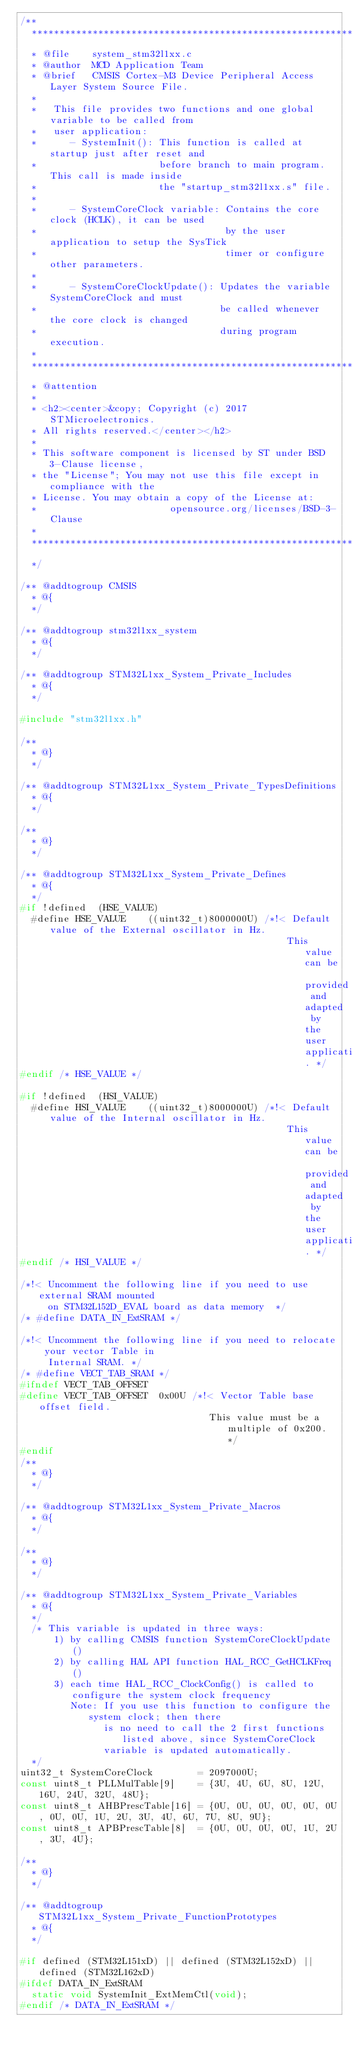<code> <loc_0><loc_0><loc_500><loc_500><_C_>/**
  ******************************************************************************
  * @file    system_stm32l1xx.c
  * @author  MCD Application Team
  * @brief   CMSIS Cortex-M3 Device Peripheral Access Layer System Source File.
  *             
  *   This file provides two functions and one global variable to be called from 
  *   user application:
  *      - SystemInit(): This function is called at startup just after reset and 
  *                      before branch to main program. This call is made inside
  *                      the "startup_stm32l1xx.s" file.
  *                        
  *      - SystemCoreClock variable: Contains the core clock (HCLK), it can be used
  *                                  by the user application to setup the SysTick 
  *                                  timer or configure other parameters.
  *                                     
  *      - SystemCoreClockUpdate(): Updates the variable SystemCoreClock and must
  *                                 be called whenever the core clock is changed
  *                                 during program execution.   
  *      
  ******************************************************************************
  * @attention
  *
  * <h2><center>&copy; Copyright (c) 2017 STMicroelectronics.
  * All rights reserved.</center></h2>
  *
  * This software component is licensed by ST under BSD 3-Clause license,
  * the "License"; You may not use this file except in compliance with the
  * License. You may obtain a copy of the License at:
  *                        opensource.org/licenses/BSD-3-Clause
  *
  ******************************************************************************
  */

/** @addtogroup CMSIS
  * @{
  */

/** @addtogroup stm32l1xx_system
  * @{
  */  
  
/** @addtogroup STM32L1xx_System_Private_Includes
  * @{
  */

#include "stm32l1xx.h"

/**
  * @}
  */

/** @addtogroup STM32L1xx_System_Private_TypesDefinitions
  * @{
  */

/**
  * @}
  */

/** @addtogroup STM32L1xx_System_Private_Defines
  * @{
  */
#if !defined  (HSE_VALUE) 
  #define HSE_VALUE    ((uint32_t)8000000U) /*!< Default value of the External oscillator in Hz.
                                                This value can be provided and adapted by the user application. */
#endif /* HSE_VALUE */

#if !defined  (HSI_VALUE)
  #define HSI_VALUE    ((uint32_t)8000000U) /*!< Default value of the Internal oscillator in Hz.
                                                This value can be provided and adapted by the user application. */
#endif /* HSI_VALUE */

/*!< Uncomment the following line if you need to use external SRAM mounted
     on STM32L152D_EVAL board as data memory  */
/* #define DATA_IN_ExtSRAM */
  
/*!< Uncomment the following line if you need to relocate your vector Table in
     Internal SRAM. */ 
/* #define VECT_TAB_SRAM */
#ifndef VECT_TAB_OFFSET
#define VECT_TAB_OFFSET  0x00U /*!< Vector Table base offset field. 
                                  This value must be a multiple of 0x200. */
#endif
/**
  * @}
  */

/** @addtogroup STM32L1xx_System_Private_Macros
  * @{
  */

/**
  * @}
  */

/** @addtogroup STM32L1xx_System_Private_Variables
  * @{
  */
  /* This variable is updated in three ways:
      1) by calling CMSIS function SystemCoreClockUpdate()
      2) by calling HAL API function HAL_RCC_GetHCLKFreq()
      3) each time HAL_RCC_ClockConfig() is called to configure the system clock frequency
         Note: If you use this function to configure the system clock; then there
               is no need to call the 2 first functions listed above, since SystemCoreClock
               variable is updated automatically.
  */
uint32_t SystemCoreClock        = 2097000U;
const uint8_t PLLMulTable[9]    = {3U, 4U, 6U, 8U, 12U, 16U, 24U, 32U, 48U};
const uint8_t AHBPrescTable[16] = {0U, 0U, 0U, 0U, 0U, 0U, 0U, 0U, 1U, 2U, 3U, 4U, 6U, 7U, 8U, 9U};
const uint8_t APBPrescTable[8]  = {0U, 0U, 0U, 0U, 1U, 2U, 3U, 4U};

/**
  * @}
  */

/** @addtogroup STM32L1xx_System_Private_FunctionPrototypes
  * @{
  */

#if defined (STM32L151xD) || defined (STM32L152xD) || defined (STM32L162xD)
#ifdef DATA_IN_ExtSRAM
  static void SystemInit_ExtMemCtl(void); 
#endif /* DATA_IN_ExtSRAM */</code> 